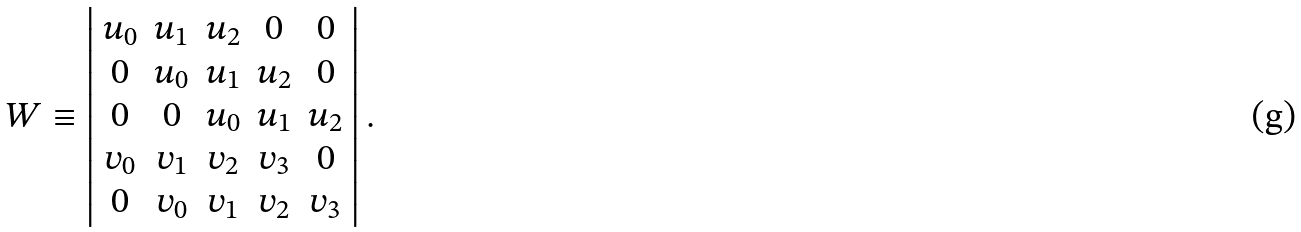Convert formula to latex. <formula><loc_0><loc_0><loc_500><loc_500>W \equiv \left | \begin{array} { c c c c c } u _ { 0 } & u _ { 1 } & u _ { 2 } & 0 & 0 \\ 0 & u _ { 0 } & u _ { 1 } & u _ { 2 } & 0 \\ 0 & 0 & u _ { 0 } & u _ { 1 } & u _ { 2 } \\ v _ { 0 } & v _ { 1 } & v _ { 2 } & v _ { 3 } & 0 \\ 0 & v _ { 0 } & v _ { 1 } & v _ { 2 } & v _ { 3 } \\ \end{array} \right | .</formula> 